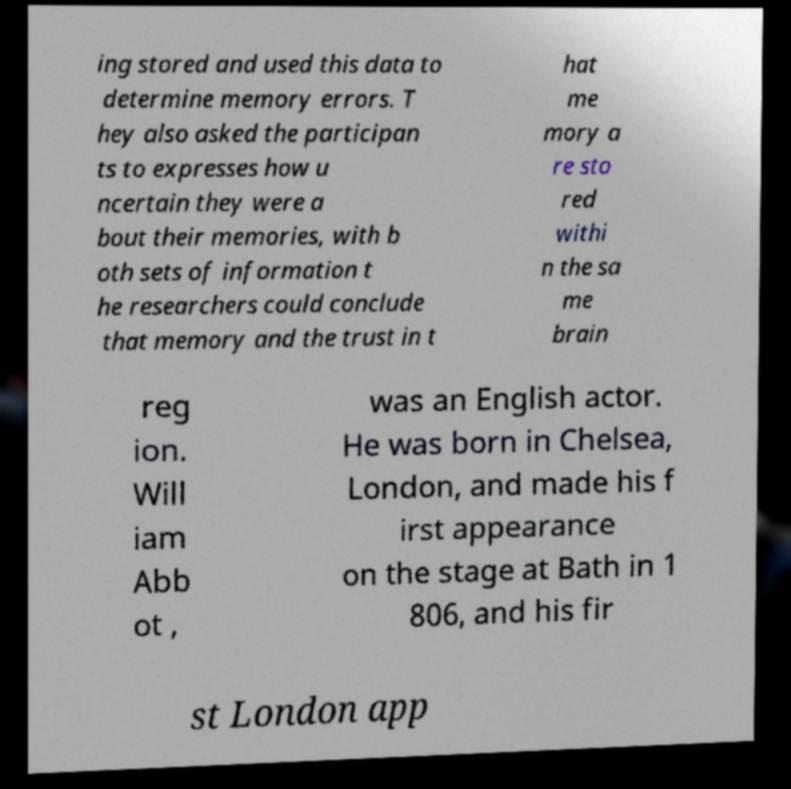I need the written content from this picture converted into text. Can you do that? ing stored and used this data to determine memory errors. T hey also asked the participan ts to expresses how u ncertain they were a bout their memories, with b oth sets of information t he researchers could conclude that memory and the trust in t hat me mory a re sto red withi n the sa me brain reg ion. Will iam Abb ot , was an English actor. He was born in Chelsea, London, and made his f irst appearance on the stage at Bath in 1 806, and his fir st London app 